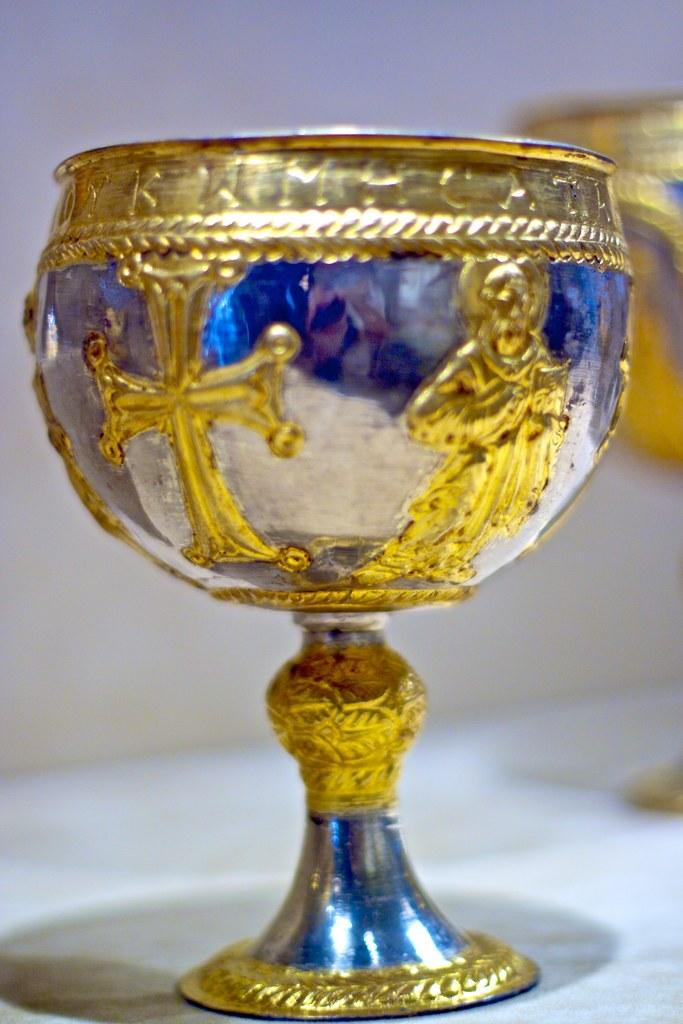What objects are placed on the table in the image? There are vessels placed on a table in the image. What can be seen in the background of the image? There is a wall in the background of the image. What type of dress is the metal wearing in the image? There is no metal or dress present in the image. The image only features vessels placed on a table and a wall in the background. 